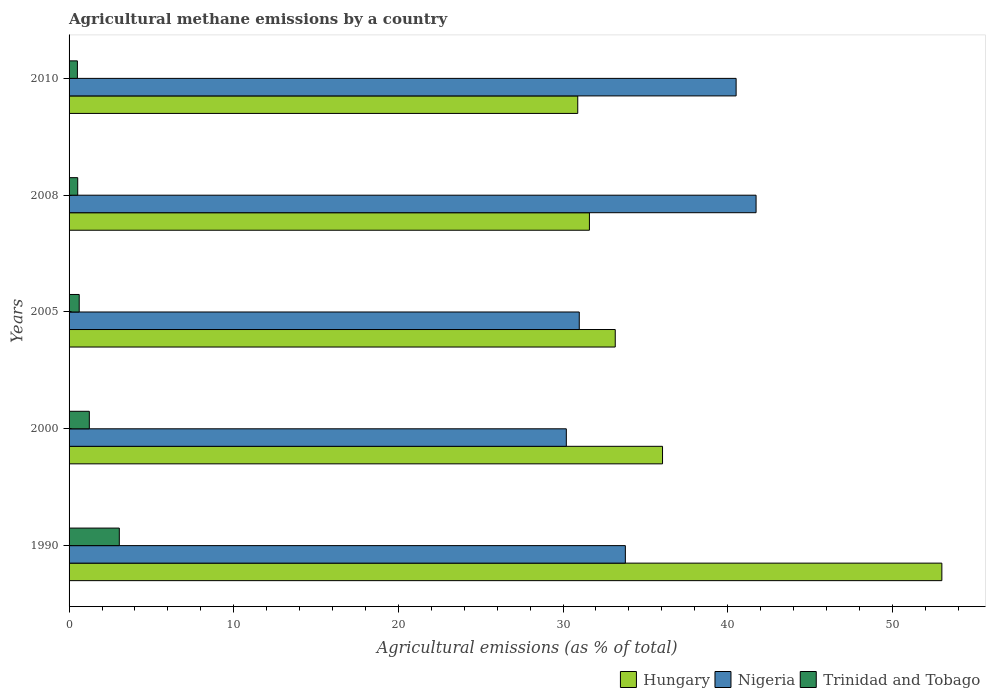How many groups of bars are there?
Your answer should be compact. 5. Are the number of bars on each tick of the Y-axis equal?
Offer a terse response. Yes. How many bars are there on the 4th tick from the bottom?
Provide a short and direct response. 3. What is the amount of agricultural methane emitted in Nigeria in 1990?
Offer a very short reply. 33.79. Across all years, what is the maximum amount of agricultural methane emitted in Trinidad and Tobago?
Give a very brief answer. 3.05. Across all years, what is the minimum amount of agricultural methane emitted in Nigeria?
Make the answer very short. 30.2. In which year was the amount of agricultural methane emitted in Nigeria maximum?
Make the answer very short. 2008. In which year was the amount of agricultural methane emitted in Hungary minimum?
Your answer should be compact. 2010. What is the total amount of agricultural methane emitted in Hungary in the graph?
Your response must be concise. 184.72. What is the difference between the amount of agricultural methane emitted in Hungary in 2000 and that in 2005?
Give a very brief answer. 2.87. What is the difference between the amount of agricultural methane emitted in Hungary in 2000 and the amount of agricultural methane emitted in Trinidad and Tobago in 2008?
Your answer should be compact. 35.52. What is the average amount of agricultural methane emitted in Hungary per year?
Ensure brevity in your answer.  36.94. In the year 2008, what is the difference between the amount of agricultural methane emitted in Hungary and amount of agricultural methane emitted in Nigeria?
Provide a short and direct response. -10.12. In how many years, is the amount of agricultural methane emitted in Hungary greater than 46 %?
Ensure brevity in your answer.  1. What is the ratio of the amount of agricultural methane emitted in Nigeria in 1990 to that in 2008?
Provide a short and direct response. 0.81. Is the amount of agricultural methane emitted in Hungary in 2000 less than that in 2008?
Keep it short and to the point. No. Is the difference between the amount of agricultural methane emitted in Hungary in 2008 and 2010 greater than the difference between the amount of agricultural methane emitted in Nigeria in 2008 and 2010?
Your answer should be very brief. No. What is the difference between the highest and the second highest amount of agricultural methane emitted in Nigeria?
Keep it short and to the point. 1.21. What is the difference between the highest and the lowest amount of agricultural methane emitted in Nigeria?
Offer a terse response. 11.52. In how many years, is the amount of agricultural methane emitted in Nigeria greater than the average amount of agricultural methane emitted in Nigeria taken over all years?
Your response must be concise. 2. What does the 1st bar from the top in 2005 represents?
Your answer should be compact. Trinidad and Tobago. What does the 1st bar from the bottom in 2008 represents?
Ensure brevity in your answer.  Hungary. Is it the case that in every year, the sum of the amount of agricultural methane emitted in Hungary and amount of agricultural methane emitted in Nigeria is greater than the amount of agricultural methane emitted in Trinidad and Tobago?
Provide a succinct answer. Yes. What is the difference between two consecutive major ticks on the X-axis?
Your response must be concise. 10. Are the values on the major ticks of X-axis written in scientific E-notation?
Your answer should be very brief. No. Does the graph contain any zero values?
Provide a short and direct response. No. How many legend labels are there?
Provide a succinct answer. 3. How are the legend labels stacked?
Offer a terse response. Horizontal. What is the title of the graph?
Provide a short and direct response. Agricultural methane emissions by a country. Does "Lithuania" appear as one of the legend labels in the graph?
Your response must be concise. No. What is the label or title of the X-axis?
Make the answer very short. Agricultural emissions (as % of total). What is the Agricultural emissions (as % of total) in Hungary in 1990?
Provide a succinct answer. 53.01. What is the Agricultural emissions (as % of total) in Nigeria in 1990?
Provide a short and direct response. 33.79. What is the Agricultural emissions (as % of total) in Trinidad and Tobago in 1990?
Give a very brief answer. 3.05. What is the Agricultural emissions (as % of total) in Hungary in 2000?
Offer a terse response. 36.04. What is the Agricultural emissions (as % of total) in Nigeria in 2000?
Your answer should be compact. 30.2. What is the Agricultural emissions (as % of total) of Trinidad and Tobago in 2000?
Provide a short and direct response. 1.23. What is the Agricultural emissions (as % of total) of Hungary in 2005?
Offer a terse response. 33.17. What is the Agricultural emissions (as % of total) in Nigeria in 2005?
Provide a short and direct response. 30.99. What is the Agricultural emissions (as % of total) in Trinidad and Tobago in 2005?
Your answer should be very brief. 0.62. What is the Agricultural emissions (as % of total) in Hungary in 2008?
Keep it short and to the point. 31.6. What is the Agricultural emissions (as % of total) of Nigeria in 2008?
Your response must be concise. 41.73. What is the Agricultural emissions (as % of total) of Trinidad and Tobago in 2008?
Give a very brief answer. 0.53. What is the Agricultural emissions (as % of total) in Hungary in 2010?
Provide a succinct answer. 30.9. What is the Agricultural emissions (as % of total) in Nigeria in 2010?
Make the answer very short. 40.51. What is the Agricultural emissions (as % of total) of Trinidad and Tobago in 2010?
Give a very brief answer. 0.51. Across all years, what is the maximum Agricultural emissions (as % of total) in Hungary?
Make the answer very short. 53.01. Across all years, what is the maximum Agricultural emissions (as % of total) in Nigeria?
Make the answer very short. 41.73. Across all years, what is the maximum Agricultural emissions (as % of total) of Trinidad and Tobago?
Your answer should be compact. 3.05. Across all years, what is the minimum Agricultural emissions (as % of total) in Hungary?
Provide a short and direct response. 30.9. Across all years, what is the minimum Agricultural emissions (as % of total) in Nigeria?
Give a very brief answer. 30.2. Across all years, what is the minimum Agricultural emissions (as % of total) of Trinidad and Tobago?
Keep it short and to the point. 0.51. What is the total Agricultural emissions (as % of total) in Hungary in the graph?
Your answer should be very brief. 184.72. What is the total Agricultural emissions (as % of total) in Nigeria in the graph?
Offer a terse response. 177.21. What is the total Agricultural emissions (as % of total) in Trinidad and Tobago in the graph?
Your answer should be very brief. 5.93. What is the difference between the Agricultural emissions (as % of total) of Hungary in 1990 and that in 2000?
Provide a short and direct response. 16.96. What is the difference between the Agricultural emissions (as % of total) of Nigeria in 1990 and that in 2000?
Give a very brief answer. 3.58. What is the difference between the Agricultural emissions (as % of total) of Trinidad and Tobago in 1990 and that in 2000?
Provide a short and direct response. 1.82. What is the difference between the Agricultural emissions (as % of total) of Hungary in 1990 and that in 2005?
Provide a succinct answer. 19.84. What is the difference between the Agricultural emissions (as % of total) of Nigeria in 1990 and that in 2005?
Provide a short and direct response. 2.8. What is the difference between the Agricultural emissions (as % of total) of Trinidad and Tobago in 1990 and that in 2005?
Give a very brief answer. 2.44. What is the difference between the Agricultural emissions (as % of total) of Hungary in 1990 and that in 2008?
Provide a short and direct response. 21.41. What is the difference between the Agricultural emissions (as % of total) in Nigeria in 1990 and that in 2008?
Give a very brief answer. -7.94. What is the difference between the Agricultural emissions (as % of total) of Trinidad and Tobago in 1990 and that in 2008?
Offer a very short reply. 2.53. What is the difference between the Agricultural emissions (as % of total) in Hungary in 1990 and that in 2010?
Your answer should be very brief. 22.11. What is the difference between the Agricultural emissions (as % of total) of Nigeria in 1990 and that in 2010?
Your answer should be very brief. -6.73. What is the difference between the Agricultural emissions (as % of total) in Trinidad and Tobago in 1990 and that in 2010?
Offer a very short reply. 2.55. What is the difference between the Agricultural emissions (as % of total) of Hungary in 2000 and that in 2005?
Provide a short and direct response. 2.87. What is the difference between the Agricultural emissions (as % of total) in Nigeria in 2000 and that in 2005?
Offer a terse response. -0.79. What is the difference between the Agricultural emissions (as % of total) in Trinidad and Tobago in 2000 and that in 2005?
Ensure brevity in your answer.  0.61. What is the difference between the Agricultural emissions (as % of total) in Hungary in 2000 and that in 2008?
Your response must be concise. 4.44. What is the difference between the Agricultural emissions (as % of total) in Nigeria in 2000 and that in 2008?
Offer a very short reply. -11.52. What is the difference between the Agricultural emissions (as % of total) of Trinidad and Tobago in 2000 and that in 2008?
Offer a very short reply. 0.7. What is the difference between the Agricultural emissions (as % of total) of Hungary in 2000 and that in 2010?
Provide a short and direct response. 5.15. What is the difference between the Agricultural emissions (as % of total) of Nigeria in 2000 and that in 2010?
Give a very brief answer. -10.31. What is the difference between the Agricultural emissions (as % of total) of Trinidad and Tobago in 2000 and that in 2010?
Keep it short and to the point. 0.72. What is the difference between the Agricultural emissions (as % of total) of Hungary in 2005 and that in 2008?
Offer a very short reply. 1.57. What is the difference between the Agricultural emissions (as % of total) of Nigeria in 2005 and that in 2008?
Provide a succinct answer. -10.74. What is the difference between the Agricultural emissions (as % of total) in Trinidad and Tobago in 2005 and that in 2008?
Provide a succinct answer. 0.09. What is the difference between the Agricultural emissions (as % of total) of Hungary in 2005 and that in 2010?
Keep it short and to the point. 2.28. What is the difference between the Agricultural emissions (as % of total) in Nigeria in 2005 and that in 2010?
Provide a succinct answer. -9.53. What is the difference between the Agricultural emissions (as % of total) of Trinidad and Tobago in 2005 and that in 2010?
Provide a short and direct response. 0.11. What is the difference between the Agricultural emissions (as % of total) in Hungary in 2008 and that in 2010?
Your response must be concise. 0.71. What is the difference between the Agricultural emissions (as % of total) of Nigeria in 2008 and that in 2010?
Provide a short and direct response. 1.21. What is the difference between the Agricultural emissions (as % of total) in Trinidad and Tobago in 2008 and that in 2010?
Offer a very short reply. 0.02. What is the difference between the Agricultural emissions (as % of total) in Hungary in 1990 and the Agricultural emissions (as % of total) in Nigeria in 2000?
Your response must be concise. 22.81. What is the difference between the Agricultural emissions (as % of total) in Hungary in 1990 and the Agricultural emissions (as % of total) in Trinidad and Tobago in 2000?
Your answer should be very brief. 51.78. What is the difference between the Agricultural emissions (as % of total) of Nigeria in 1990 and the Agricultural emissions (as % of total) of Trinidad and Tobago in 2000?
Make the answer very short. 32.56. What is the difference between the Agricultural emissions (as % of total) of Hungary in 1990 and the Agricultural emissions (as % of total) of Nigeria in 2005?
Ensure brevity in your answer.  22.02. What is the difference between the Agricultural emissions (as % of total) in Hungary in 1990 and the Agricultural emissions (as % of total) in Trinidad and Tobago in 2005?
Your answer should be compact. 52.39. What is the difference between the Agricultural emissions (as % of total) of Nigeria in 1990 and the Agricultural emissions (as % of total) of Trinidad and Tobago in 2005?
Offer a very short reply. 33.17. What is the difference between the Agricultural emissions (as % of total) in Hungary in 1990 and the Agricultural emissions (as % of total) in Nigeria in 2008?
Keep it short and to the point. 11.28. What is the difference between the Agricultural emissions (as % of total) of Hungary in 1990 and the Agricultural emissions (as % of total) of Trinidad and Tobago in 2008?
Your response must be concise. 52.48. What is the difference between the Agricultural emissions (as % of total) of Nigeria in 1990 and the Agricultural emissions (as % of total) of Trinidad and Tobago in 2008?
Your answer should be compact. 33.26. What is the difference between the Agricultural emissions (as % of total) of Hungary in 1990 and the Agricultural emissions (as % of total) of Nigeria in 2010?
Offer a very short reply. 12.5. What is the difference between the Agricultural emissions (as % of total) in Hungary in 1990 and the Agricultural emissions (as % of total) in Trinidad and Tobago in 2010?
Your answer should be compact. 52.5. What is the difference between the Agricultural emissions (as % of total) in Nigeria in 1990 and the Agricultural emissions (as % of total) in Trinidad and Tobago in 2010?
Ensure brevity in your answer.  33.28. What is the difference between the Agricultural emissions (as % of total) of Hungary in 2000 and the Agricultural emissions (as % of total) of Nigeria in 2005?
Your answer should be compact. 5.06. What is the difference between the Agricultural emissions (as % of total) of Hungary in 2000 and the Agricultural emissions (as % of total) of Trinidad and Tobago in 2005?
Your answer should be compact. 35.43. What is the difference between the Agricultural emissions (as % of total) in Nigeria in 2000 and the Agricultural emissions (as % of total) in Trinidad and Tobago in 2005?
Provide a succinct answer. 29.59. What is the difference between the Agricultural emissions (as % of total) in Hungary in 2000 and the Agricultural emissions (as % of total) in Nigeria in 2008?
Make the answer very short. -5.68. What is the difference between the Agricultural emissions (as % of total) in Hungary in 2000 and the Agricultural emissions (as % of total) in Trinidad and Tobago in 2008?
Ensure brevity in your answer.  35.52. What is the difference between the Agricultural emissions (as % of total) in Nigeria in 2000 and the Agricultural emissions (as % of total) in Trinidad and Tobago in 2008?
Your answer should be very brief. 29.68. What is the difference between the Agricultural emissions (as % of total) of Hungary in 2000 and the Agricultural emissions (as % of total) of Nigeria in 2010?
Ensure brevity in your answer.  -4.47. What is the difference between the Agricultural emissions (as % of total) of Hungary in 2000 and the Agricultural emissions (as % of total) of Trinidad and Tobago in 2010?
Keep it short and to the point. 35.54. What is the difference between the Agricultural emissions (as % of total) in Nigeria in 2000 and the Agricultural emissions (as % of total) in Trinidad and Tobago in 2010?
Ensure brevity in your answer.  29.7. What is the difference between the Agricultural emissions (as % of total) in Hungary in 2005 and the Agricultural emissions (as % of total) in Nigeria in 2008?
Your response must be concise. -8.55. What is the difference between the Agricultural emissions (as % of total) of Hungary in 2005 and the Agricultural emissions (as % of total) of Trinidad and Tobago in 2008?
Your answer should be very brief. 32.65. What is the difference between the Agricultural emissions (as % of total) in Nigeria in 2005 and the Agricultural emissions (as % of total) in Trinidad and Tobago in 2008?
Your response must be concise. 30.46. What is the difference between the Agricultural emissions (as % of total) of Hungary in 2005 and the Agricultural emissions (as % of total) of Nigeria in 2010?
Offer a very short reply. -7.34. What is the difference between the Agricultural emissions (as % of total) of Hungary in 2005 and the Agricultural emissions (as % of total) of Trinidad and Tobago in 2010?
Provide a succinct answer. 32.67. What is the difference between the Agricultural emissions (as % of total) of Nigeria in 2005 and the Agricultural emissions (as % of total) of Trinidad and Tobago in 2010?
Your answer should be compact. 30.48. What is the difference between the Agricultural emissions (as % of total) in Hungary in 2008 and the Agricultural emissions (as % of total) in Nigeria in 2010?
Your answer should be very brief. -8.91. What is the difference between the Agricultural emissions (as % of total) in Hungary in 2008 and the Agricultural emissions (as % of total) in Trinidad and Tobago in 2010?
Make the answer very short. 31.1. What is the difference between the Agricultural emissions (as % of total) of Nigeria in 2008 and the Agricultural emissions (as % of total) of Trinidad and Tobago in 2010?
Keep it short and to the point. 41.22. What is the average Agricultural emissions (as % of total) of Hungary per year?
Give a very brief answer. 36.94. What is the average Agricultural emissions (as % of total) of Nigeria per year?
Offer a very short reply. 35.44. What is the average Agricultural emissions (as % of total) of Trinidad and Tobago per year?
Provide a succinct answer. 1.19. In the year 1990, what is the difference between the Agricultural emissions (as % of total) of Hungary and Agricultural emissions (as % of total) of Nigeria?
Provide a short and direct response. 19.22. In the year 1990, what is the difference between the Agricultural emissions (as % of total) of Hungary and Agricultural emissions (as % of total) of Trinidad and Tobago?
Provide a short and direct response. 49.96. In the year 1990, what is the difference between the Agricultural emissions (as % of total) in Nigeria and Agricultural emissions (as % of total) in Trinidad and Tobago?
Your answer should be very brief. 30.73. In the year 2000, what is the difference between the Agricultural emissions (as % of total) in Hungary and Agricultural emissions (as % of total) in Nigeria?
Keep it short and to the point. 5.84. In the year 2000, what is the difference between the Agricultural emissions (as % of total) in Hungary and Agricultural emissions (as % of total) in Trinidad and Tobago?
Offer a terse response. 34.81. In the year 2000, what is the difference between the Agricultural emissions (as % of total) in Nigeria and Agricultural emissions (as % of total) in Trinidad and Tobago?
Offer a very short reply. 28.97. In the year 2005, what is the difference between the Agricultural emissions (as % of total) of Hungary and Agricultural emissions (as % of total) of Nigeria?
Your answer should be compact. 2.19. In the year 2005, what is the difference between the Agricultural emissions (as % of total) of Hungary and Agricultural emissions (as % of total) of Trinidad and Tobago?
Give a very brief answer. 32.56. In the year 2005, what is the difference between the Agricultural emissions (as % of total) in Nigeria and Agricultural emissions (as % of total) in Trinidad and Tobago?
Offer a terse response. 30.37. In the year 2008, what is the difference between the Agricultural emissions (as % of total) in Hungary and Agricultural emissions (as % of total) in Nigeria?
Provide a short and direct response. -10.12. In the year 2008, what is the difference between the Agricultural emissions (as % of total) in Hungary and Agricultural emissions (as % of total) in Trinidad and Tobago?
Make the answer very short. 31.08. In the year 2008, what is the difference between the Agricultural emissions (as % of total) in Nigeria and Agricultural emissions (as % of total) in Trinidad and Tobago?
Your answer should be very brief. 41.2. In the year 2010, what is the difference between the Agricultural emissions (as % of total) in Hungary and Agricultural emissions (as % of total) in Nigeria?
Your response must be concise. -9.62. In the year 2010, what is the difference between the Agricultural emissions (as % of total) of Hungary and Agricultural emissions (as % of total) of Trinidad and Tobago?
Ensure brevity in your answer.  30.39. In the year 2010, what is the difference between the Agricultural emissions (as % of total) of Nigeria and Agricultural emissions (as % of total) of Trinidad and Tobago?
Give a very brief answer. 40.01. What is the ratio of the Agricultural emissions (as % of total) in Hungary in 1990 to that in 2000?
Your answer should be very brief. 1.47. What is the ratio of the Agricultural emissions (as % of total) in Nigeria in 1990 to that in 2000?
Your answer should be very brief. 1.12. What is the ratio of the Agricultural emissions (as % of total) in Trinidad and Tobago in 1990 to that in 2000?
Provide a succinct answer. 2.48. What is the ratio of the Agricultural emissions (as % of total) in Hungary in 1990 to that in 2005?
Keep it short and to the point. 1.6. What is the ratio of the Agricultural emissions (as % of total) in Nigeria in 1990 to that in 2005?
Make the answer very short. 1.09. What is the ratio of the Agricultural emissions (as % of total) of Trinidad and Tobago in 1990 to that in 2005?
Your response must be concise. 4.95. What is the ratio of the Agricultural emissions (as % of total) in Hungary in 1990 to that in 2008?
Your response must be concise. 1.68. What is the ratio of the Agricultural emissions (as % of total) in Nigeria in 1990 to that in 2008?
Offer a terse response. 0.81. What is the ratio of the Agricultural emissions (as % of total) in Trinidad and Tobago in 1990 to that in 2008?
Keep it short and to the point. 5.81. What is the ratio of the Agricultural emissions (as % of total) of Hungary in 1990 to that in 2010?
Your answer should be very brief. 1.72. What is the ratio of the Agricultural emissions (as % of total) in Nigeria in 1990 to that in 2010?
Keep it short and to the point. 0.83. What is the ratio of the Agricultural emissions (as % of total) in Trinidad and Tobago in 1990 to that in 2010?
Offer a terse response. 6.03. What is the ratio of the Agricultural emissions (as % of total) of Hungary in 2000 to that in 2005?
Make the answer very short. 1.09. What is the ratio of the Agricultural emissions (as % of total) in Nigeria in 2000 to that in 2005?
Make the answer very short. 0.97. What is the ratio of the Agricultural emissions (as % of total) in Trinidad and Tobago in 2000 to that in 2005?
Keep it short and to the point. 2. What is the ratio of the Agricultural emissions (as % of total) of Hungary in 2000 to that in 2008?
Keep it short and to the point. 1.14. What is the ratio of the Agricultural emissions (as % of total) in Nigeria in 2000 to that in 2008?
Provide a succinct answer. 0.72. What is the ratio of the Agricultural emissions (as % of total) of Trinidad and Tobago in 2000 to that in 2008?
Offer a very short reply. 2.34. What is the ratio of the Agricultural emissions (as % of total) in Hungary in 2000 to that in 2010?
Offer a terse response. 1.17. What is the ratio of the Agricultural emissions (as % of total) in Nigeria in 2000 to that in 2010?
Offer a terse response. 0.75. What is the ratio of the Agricultural emissions (as % of total) in Trinidad and Tobago in 2000 to that in 2010?
Keep it short and to the point. 2.43. What is the ratio of the Agricultural emissions (as % of total) of Hungary in 2005 to that in 2008?
Offer a terse response. 1.05. What is the ratio of the Agricultural emissions (as % of total) in Nigeria in 2005 to that in 2008?
Ensure brevity in your answer.  0.74. What is the ratio of the Agricultural emissions (as % of total) of Trinidad and Tobago in 2005 to that in 2008?
Give a very brief answer. 1.17. What is the ratio of the Agricultural emissions (as % of total) in Hungary in 2005 to that in 2010?
Ensure brevity in your answer.  1.07. What is the ratio of the Agricultural emissions (as % of total) of Nigeria in 2005 to that in 2010?
Offer a terse response. 0.76. What is the ratio of the Agricultural emissions (as % of total) of Trinidad and Tobago in 2005 to that in 2010?
Provide a short and direct response. 1.22. What is the ratio of the Agricultural emissions (as % of total) of Hungary in 2008 to that in 2010?
Make the answer very short. 1.02. What is the ratio of the Agricultural emissions (as % of total) of Nigeria in 2008 to that in 2010?
Provide a short and direct response. 1.03. What is the ratio of the Agricultural emissions (as % of total) of Trinidad and Tobago in 2008 to that in 2010?
Give a very brief answer. 1.04. What is the difference between the highest and the second highest Agricultural emissions (as % of total) in Hungary?
Offer a terse response. 16.96. What is the difference between the highest and the second highest Agricultural emissions (as % of total) of Nigeria?
Make the answer very short. 1.21. What is the difference between the highest and the second highest Agricultural emissions (as % of total) in Trinidad and Tobago?
Provide a short and direct response. 1.82. What is the difference between the highest and the lowest Agricultural emissions (as % of total) in Hungary?
Provide a short and direct response. 22.11. What is the difference between the highest and the lowest Agricultural emissions (as % of total) of Nigeria?
Your response must be concise. 11.52. What is the difference between the highest and the lowest Agricultural emissions (as % of total) in Trinidad and Tobago?
Provide a succinct answer. 2.55. 